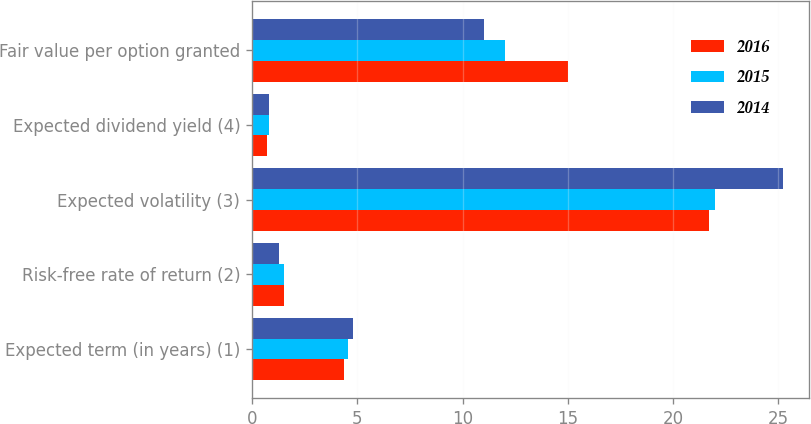Convert chart. <chart><loc_0><loc_0><loc_500><loc_500><stacked_bar_chart><ecel><fcel>Expected term (in years) (1)<fcel>Risk-free rate of return (2)<fcel>Expected volatility (3)<fcel>Expected dividend yield (4)<fcel>Fair value per option granted<nl><fcel>2016<fcel>4.35<fcel>1.5<fcel>21.7<fcel>0.7<fcel>15.01<nl><fcel>2015<fcel>4.55<fcel>1.5<fcel>22<fcel>0.8<fcel>12.04<nl><fcel>2014<fcel>4.8<fcel>1.3<fcel>25.2<fcel>0.8<fcel>11.03<nl></chart> 